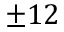Convert formula to latex. <formula><loc_0><loc_0><loc_500><loc_500>\pm 1 2</formula> 